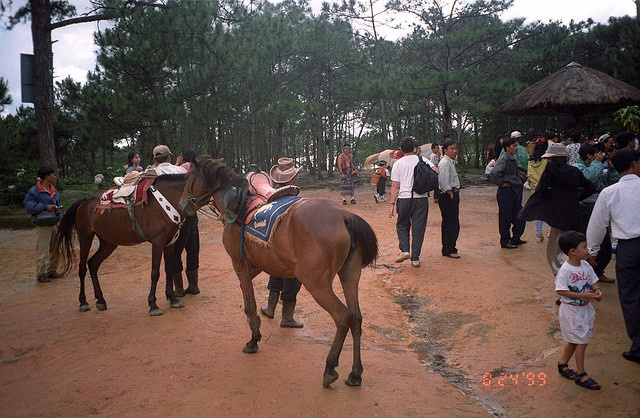Describe the objects in this image and their specific colors. I can see horse in gray, maroon, black, and brown tones, people in gray, black, and maroon tones, horse in gray, black, and maroon tones, people in gray, black, and darkgray tones, and umbrella in gray and black tones in this image. 